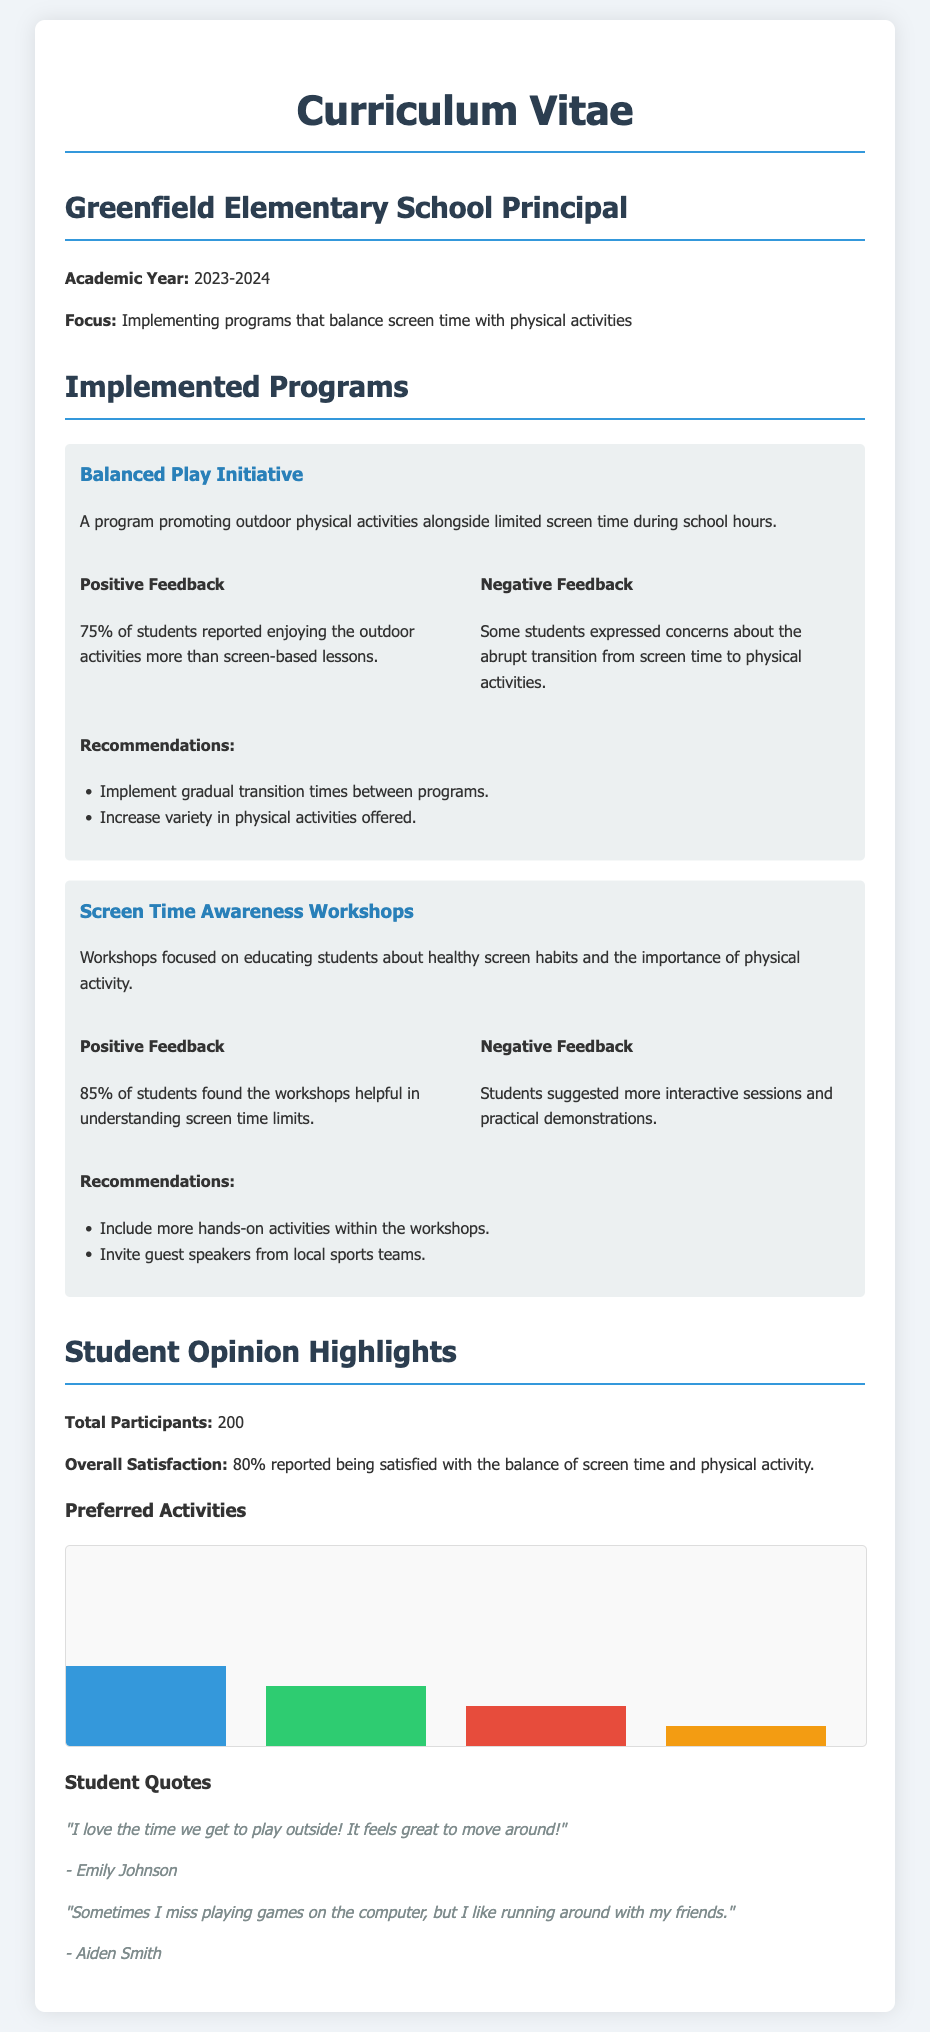what is the name of the principal? The document provides the title but does not specify the principal's name.
Answer: Greenfield Elementary School Principal what is the focus of the academic year? The focus is stated in the introduction of the document, highlighting the main goal for the year.
Answer: Implementing programs that balance screen time with physical activities how many students participated in the feedback survey? The total number of participants is directly mentioned in the Student Opinion Highlights section.
Answer: 200 what percentage of students reported enjoying outdoor activities more than screen-based lessons? The specific percentage is mentioned under the Balanced Play Initiative feedback.
Answer: 75% what was the overall satisfaction percentage regarding the balance of screen time and physical activity? This information is also found in the Student Opinion Highlights section of the document.
Answer: 80% what are the two main recommendations for the Balanced Play Initiative? The recommendations are listed directly after the feedback in the relevant program section.
Answer: Implement gradual transition times between programs; Increase variety in physical activities offered which outdoor activity was preferred by the highest percentage of students? The preference is indicated in the Preferred Activities chart.
Answer: Soccer what did Aiden Smith express about his feelings toward screen time? This sentiment is encapsulated in a quote from the student.
Answer: "Sometimes I miss playing games on the computer..." what is the suggested improvement for the Screen Time Awareness Workshops? This information comes from the negative feedback section regarding the workshops.
Answer: Include more hands-on activities within the workshops 